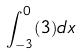<formula> <loc_0><loc_0><loc_500><loc_500>\int _ { - 3 } ^ { 0 } ( 3 ) d x</formula> 